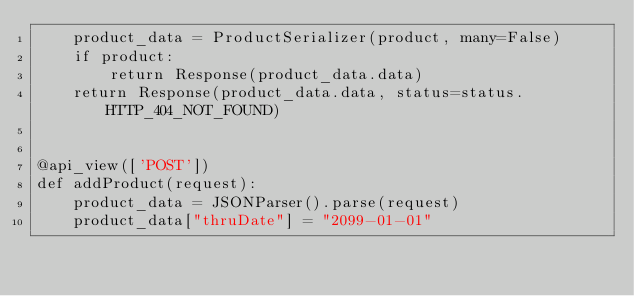<code> <loc_0><loc_0><loc_500><loc_500><_Python_>    product_data = ProductSerializer(product, many=False)
    if product:
        return Response(product_data.data)
    return Response(product_data.data, status=status.HTTP_404_NOT_FOUND)


@api_view(['POST'])
def addProduct(request):
    product_data = JSONParser().parse(request)
    product_data["thruDate"] = "2099-01-01"</code> 